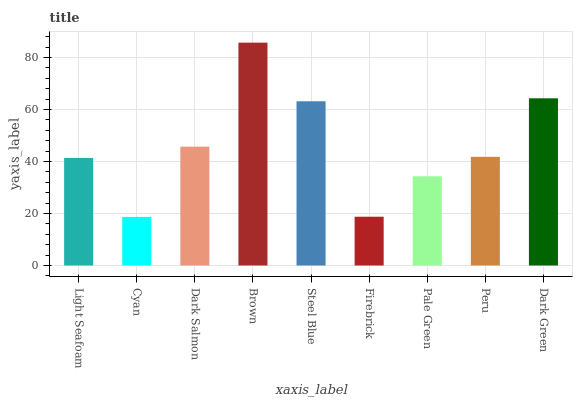Is Cyan the minimum?
Answer yes or no. Yes. Is Brown the maximum?
Answer yes or no. Yes. Is Dark Salmon the minimum?
Answer yes or no. No. Is Dark Salmon the maximum?
Answer yes or no. No. Is Dark Salmon greater than Cyan?
Answer yes or no. Yes. Is Cyan less than Dark Salmon?
Answer yes or no. Yes. Is Cyan greater than Dark Salmon?
Answer yes or no. No. Is Dark Salmon less than Cyan?
Answer yes or no. No. Is Peru the high median?
Answer yes or no. Yes. Is Peru the low median?
Answer yes or no. Yes. Is Dark Green the high median?
Answer yes or no. No. Is Firebrick the low median?
Answer yes or no. No. 